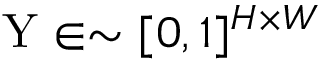Convert formula to latex. <formula><loc_0><loc_0><loc_500><loc_500>Y \in \sim [ 0 , 1 ] ^ { H \times W }</formula> 